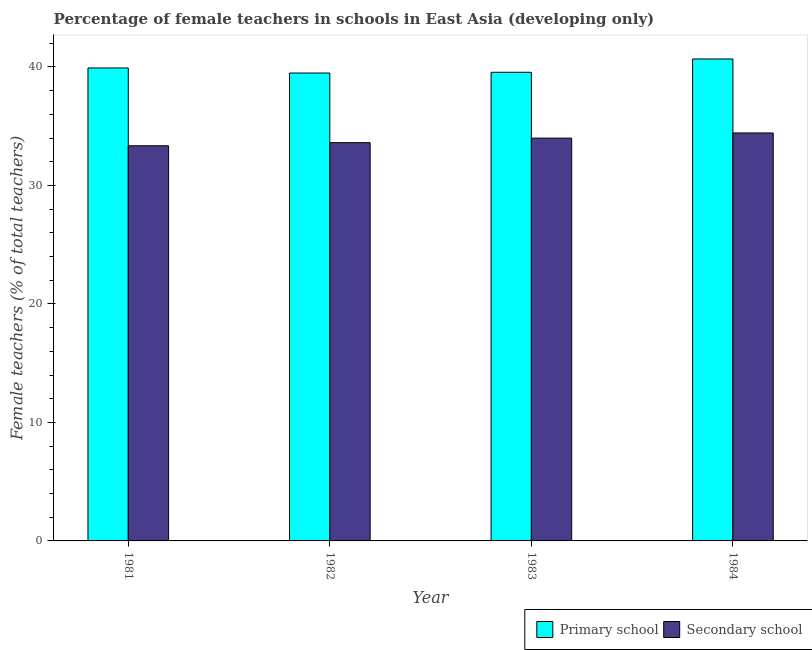Are the number of bars on each tick of the X-axis equal?
Give a very brief answer. Yes. How many bars are there on the 4th tick from the right?
Provide a succinct answer. 2. What is the label of the 1st group of bars from the left?
Give a very brief answer. 1981. In how many cases, is the number of bars for a given year not equal to the number of legend labels?
Offer a very short reply. 0. What is the percentage of female teachers in primary schools in 1984?
Your response must be concise. 40.67. Across all years, what is the maximum percentage of female teachers in secondary schools?
Ensure brevity in your answer.  34.43. Across all years, what is the minimum percentage of female teachers in primary schools?
Provide a short and direct response. 39.49. What is the total percentage of female teachers in primary schools in the graph?
Offer a terse response. 159.62. What is the difference between the percentage of female teachers in primary schools in 1981 and that in 1983?
Ensure brevity in your answer.  0.37. What is the difference between the percentage of female teachers in secondary schools in 1984 and the percentage of female teachers in primary schools in 1982?
Your answer should be very brief. 0.82. What is the average percentage of female teachers in primary schools per year?
Your response must be concise. 39.91. In the year 1983, what is the difference between the percentage of female teachers in secondary schools and percentage of female teachers in primary schools?
Provide a succinct answer. 0. What is the ratio of the percentage of female teachers in secondary schools in 1981 to that in 1984?
Ensure brevity in your answer.  0.97. What is the difference between the highest and the second highest percentage of female teachers in secondary schools?
Offer a very short reply. 0.44. What is the difference between the highest and the lowest percentage of female teachers in secondary schools?
Your answer should be very brief. 1.08. In how many years, is the percentage of female teachers in secondary schools greater than the average percentage of female teachers in secondary schools taken over all years?
Offer a very short reply. 2. Is the sum of the percentage of female teachers in primary schools in 1982 and 1984 greater than the maximum percentage of female teachers in secondary schools across all years?
Keep it short and to the point. Yes. What does the 1st bar from the left in 1984 represents?
Your answer should be compact. Primary school. What does the 1st bar from the right in 1981 represents?
Keep it short and to the point. Secondary school. How many bars are there?
Your answer should be compact. 8. What is the difference between two consecutive major ticks on the Y-axis?
Make the answer very short. 10. Are the values on the major ticks of Y-axis written in scientific E-notation?
Keep it short and to the point. No. Does the graph contain grids?
Offer a very short reply. No. Where does the legend appear in the graph?
Provide a short and direct response. Bottom right. How are the legend labels stacked?
Ensure brevity in your answer.  Horizontal. What is the title of the graph?
Give a very brief answer. Percentage of female teachers in schools in East Asia (developing only). Does "National Visitors" appear as one of the legend labels in the graph?
Offer a terse response. No. What is the label or title of the X-axis?
Give a very brief answer. Year. What is the label or title of the Y-axis?
Make the answer very short. Female teachers (% of total teachers). What is the Female teachers (% of total teachers) in Primary school in 1981?
Provide a short and direct response. 39.91. What is the Female teachers (% of total teachers) in Secondary school in 1981?
Your response must be concise. 33.35. What is the Female teachers (% of total teachers) of Primary school in 1982?
Give a very brief answer. 39.49. What is the Female teachers (% of total teachers) in Secondary school in 1982?
Your answer should be compact. 33.61. What is the Female teachers (% of total teachers) in Primary school in 1983?
Offer a terse response. 39.55. What is the Female teachers (% of total teachers) of Secondary school in 1983?
Your answer should be very brief. 33.99. What is the Female teachers (% of total teachers) of Primary school in 1984?
Keep it short and to the point. 40.67. What is the Female teachers (% of total teachers) of Secondary school in 1984?
Your response must be concise. 34.43. Across all years, what is the maximum Female teachers (% of total teachers) in Primary school?
Keep it short and to the point. 40.67. Across all years, what is the maximum Female teachers (% of total teachers) of Secondary school?
Your response must be concise. 34.43. Across all years, what is the minimum Female teachers (% of total teachers) of Primary school?
Your response must be concise. 39.49. Across all years, what is the minimum Female teachers (% of total teachers) in Secondary school?
Offer a very short reply. 33.35. What is the total Female teachers (% of total teachers) in Primary school in the graph?
Provide a short and direct response. 159.62. What is the total Female teachers (% of total teachers) of Secondary school in the graph?
Give a very brief answer. 135.38. What is the difference between the Female teachers (% of total teachers) of Primary school in 1981 and that in 1982?
Provide a short and direct response. 0.43. What is the difference between the Female teachers (% of total teachers) of Secondary school in 1981 and that in 1982?
Offer a very short reply. -0.26. What is the difference between the Female teachers (% of total teachers) in Primary school in 1981 and that in 1983?
Give a very brief answer. 0.37. What is the difference between the Female teachers (% of total teachers) in Secondary school in 1981 and that in 1983?
Ensure brevity in your answer.  -0.65. What is the difference between the Female teachers (% of total teachers) in Primary school in 1981 and that in 1984?
Your response must be concise. -0.76. What is the difference between the Female teachers (% of total teachers) of Secondary school in 1981 and that in 1984?
Provide a short and direct response. -1.08. What is the difference between the Female teachers (% of total teachers) in Primary school in 1982 and that in 1983?
Keep it short and to the point. -0.06. What is the difference between the Female teachers (% of total teachers) of Secondary school in 1982 and that in 1983?
Your answer should be very brief. -0.38. What is the difference between the Female teachers (% of total teachers) of Primary school in 1982 and that in 1984?
Give a very brief answer. -1.19. What is the difference between the Female teachers (% of total teachers) of Secondary school in 1982 and that in 1984?
Your response must be concise. -0.82. What is the difference between the Female teachers (% of total teachers) in Primary school in 1983 and that in 1984?
Ensure brevity in your answer.  -1.12. What is the difference between the Female teachers (% of total teachers) in Secondary school in 1983 and that in 1984?
Your answer should be compact. -0.44. What is the difference between the Female teachers (% of total teachers) in Primary school in 1981 and the Female teachers (% of total teachers) in Secondary school in 1982?
Offer a terse response. 6.31. What is the difference between the Female teachers (% of total teachers) in Primary school in 1981 and the Female teachers (% of total teachers) in Secondary school in 1983?
Your response must be concise. 5.92. What is the difference between the Female teachers (% of total teachers) in Primary school in 1981 and the Female teachers (% of total teachers) in Secondary school in 1984?
Keep it short and to the point. 5.49. What is the difference between the Female teachers (% of total teachers) in Primary school in 1982 and the Female teachers (% of total teachers) in Secondary school in 1983?
Your answer should be compact. 5.49. What is the difference between the Female teachers (% of total teachers) of Primary school in 1982 and the Female teachers (% of total teachers) of Secondary school in 1984?
Provide a short and direct response. 5.06. What is the difference between the Female teachers (% of total teachers) of Primary school in 1983 and the Female teachers (% of total teachers) of Secondary school in 1984?
Your answer should be very brief. 5.12. What is the average Female teachers (% of total teachers) in Primary school per year?
Provide a succinct answer. 39.91. What is the average Female teachers (% of total teachers) of Secondary school per year?
Provide a short and direct response. 33.84. In the year 1981, what is the difference between the Female teachers (% of total teachers) of Primary school and Female teachers (% of total teachers) of Secondary school?
Ensure brevity in your answer.  6.57. In the year 1982, what is the difference between the Female teachers (% of total teachers) of Primary school and Female teachers (% of total teachers) of Secondary school?
Give a very brief answer. 5.88. In the year 1983, what is the difference between the Female teachers (% of total teachers) of Primary school and Female teachers (% of total teachers) of Secondary school?
Make the answer very short. 5.56. In the year 1984, what is the difference between the Female teachers (% of total teachers) of Primary school and Female teachers (% of total teachers) of Secondary school?
Your answer should be very brief. 6.24. What is the ratio of the Female teachers (% of total teachers) of Primary school in 1981 to that in 1982?
Provide a succinct answer. 1.01. What is the ratio of the Female teachers (% of total teachers) of Secondary school in 1981 to that in 1982?
Your response must be concise. 0.99. What is the ratio of the Female teachers (% of total teachers) of Primary school in 1981 to that in 1983?
Your answer should be compact. 1.01. What is the ratio of the Female teachers (% of total teachers) of Primary school in 1981 to that in 1984?
Your answer should be very brief. 0.98. What is the ratio of the Female teachers (% of total teachers) of Secondary school in 1981 to that in 1984?
Provide a succinct answer. 0.97. What is the ratio of the Female teachers (% of total teachers) in Primary school in 1982 to that in 1983?
Keep it short and to the point. 1. What is the ratio of the Female teachers (% of total teachers) of Secondary school in 1982 to that in 1983?
Your answer should be compact. 0.99. What is the ratio of the Female teachers (% of total teachers) in Primary school in 1982 to that in 1984?
Keep it short and to the point. 0.97. What is the ratio of the Female teachers (% of total teachers) of Secondary school in 1982 to that in 1984?
Your answer should be compact. 0.98. What is the ratio of the Female teachers (% of total teachers) in Primary school in 1983 to that in 1984?
Keep it short and to the point. 0.97. What is the ratio of the Female teachers (% of total teachers) in Secondary school in 1983 to that in 1984?
Your answer should be compact. 0.99. What is the difference between the highest and the second highest Female teachers (% of total teachers) of Primary school?
Ensure brevity in your answer.  0.76. What is the difference between the highest and the second highest Female teachers (% of total teachers) of Secondary school?
Your answer should be very brief. 0.44. What is the difference between the highest and the lowest Female teachers (% of total teachers) in Primary school?
Ensure brevity in your answer.  1.19. What is the difference between the highest and the lowest Female teachers (% of total teachers) of Secondary school?
Keep it short and to the point. 1.08. 